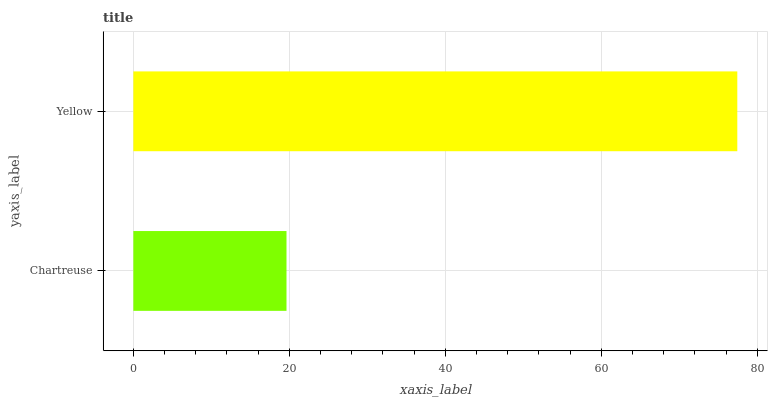Is Chartreuse the minimum?
Answer yes or no. Yes. Is Yellow the maximum?
Answer yes or no. Yes. Is Yellow the minimum?
Answer yes or no. No. Is Yellow greater than Chartreuse?
Answer yes or no. Yes. Is Chartreuse less than Yellow?
Answer yes or no. Yes. Is Chartreuse greater than Yellow?
Answer yes or no. No. Is Yellow less than Chartreuse?
Answer yes or no. No. Is Yellow the high median?
Answer yes or no. Yes. Is Chartreuse the low median?
Answer yes or no. Yes. Is Chartreuse the high median?
Answer yes or no. No. Is Yellow the low median?
Answer yes or no. No. 